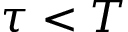<formula> <loc_0><loc_0><loc_500><loc_500>\tau < T</formula> 